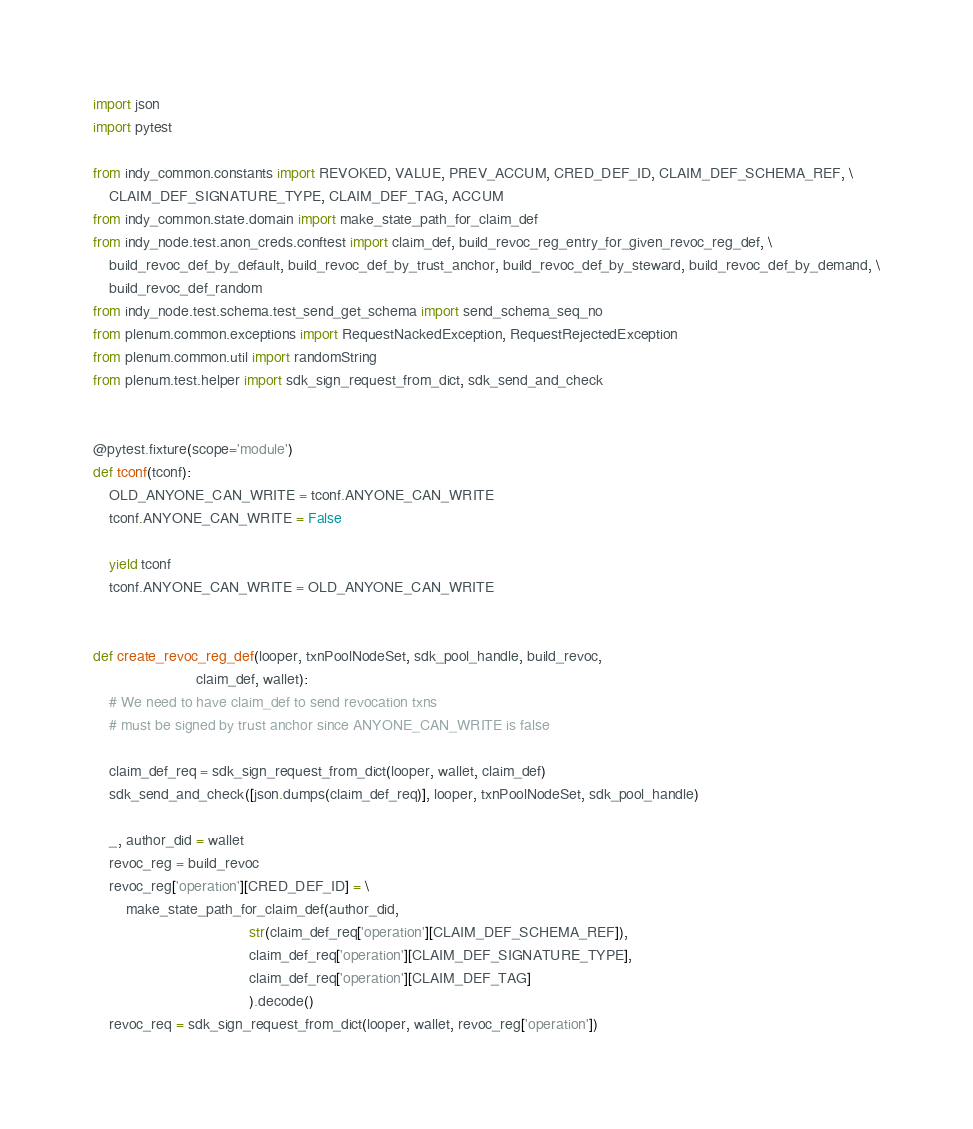<code> <loc_0><loc_0><loc_500><loc_500><_Python_>import json
import pytest

from indy_common.constants import REVOKED, VALUE, PREV_ACCUM, CRED_DEF_ID, CLAIM_DEF_SCHEMA_REF, \
    CLAIM_DEF_SIGNATURE_TYPE, CLAIM_DEF_TAG, ACCUM
from indy_common.state.domain import make_state_path_for_claim_def
from indy_node.test.anon_creds.conftest import claim_def, build_revoc_reg_entry_for_given_revoc_reg_def, \
    build_revoc_def_by_default, build_revoc_def_by_trust_anchor, build_revoc_def_by_steward, build_revoc_def_by_demand, \
    build_revoc_def_random
from indy_node.test.schema.test_send_get_schema import send_schema_seq_no
from plenum.common.exceptions import RequestNackedException, RequestRejectedException
from plenum.common.util import randomString
from plenum.test.helper import sdk_sign_request_from_dict, sdk_send_and_check


@pytest.fixture(scope='module')
def tconf(tconf):
    OLD_ANYONE_CAN_WRITE = tconf.ANYONE_CAN_WRITE
    tconf.ANYONE_CAN_WRITE = False

    yield tconf
    tconf.ANYONE_CAN_WRITE = OLD_ANYONE_CAN_WRITE


def create_revoc_reg_def(looper, txnPoolNodeSet, sdk_pool_handle, build_revoc,
                         claim_def, wallet):
    # We need to have claim_def to send revocation txns
    # must be signed by trust anchor since ANYONE_CAN_WRITE is false

    claim_def_req = sdk_sign_request_from_dict(looper, wallet, claim_def)
    sdk_send_and_check([json.dumps(claim_def_req)], looper, txnPoolNodeSet, sdk_pool_handle)

    _, author_did = wallet
    revoc_reg = build_revoc
    revoc_reg['operation'][CRED_DEF_ID] = \
        make_state_path_for_claim_def(author_did,
                                      str(claim_def_req['operation'][CLAIM_DEF_SCHEMA_REF]),
                                      claim_def_req['operation'][CLAIM_DEF_SIGNATURE_TYPE],
                                      claim_def_req['operation'][CLAIM_DEF_TAG]
                                      ).decode()
    revoc_req = sdk_sign_request_from_dict(looper, wallet, revoc_reg['operation'])</code> 